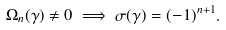<formula> <loc_0><loc_0><loc_500><loc_500>\Omega _ { n } ( \gamma ) \neq 0 \implies \sigma ( \gamma ) = ( - 1 ) ^ { n + 1 } .</formula> 